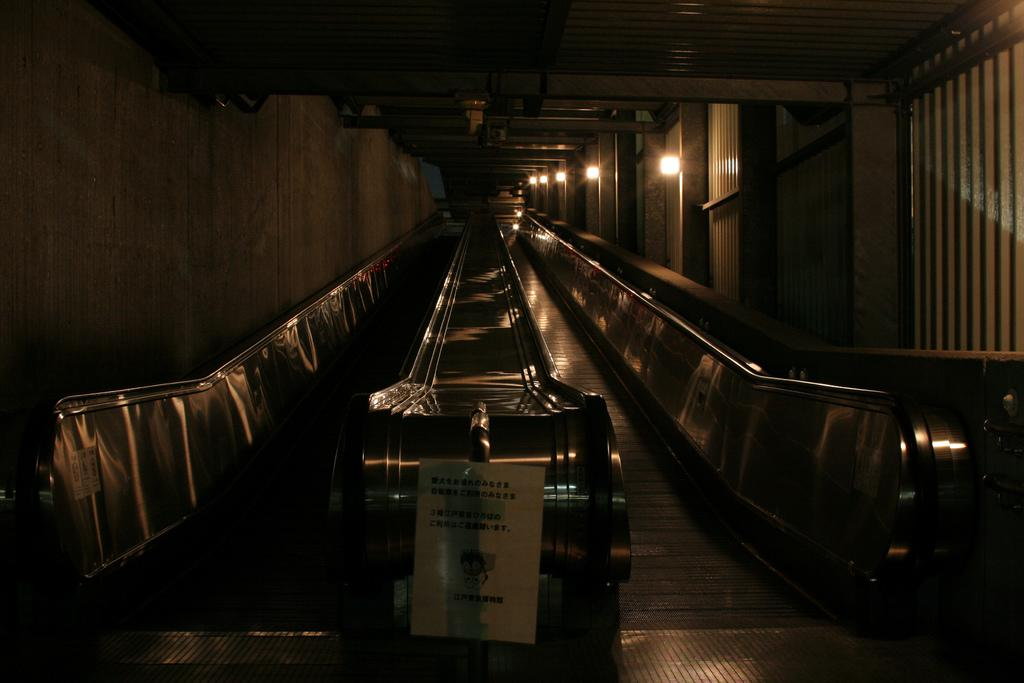What type of transportation device is present in the image? There is an escalator in the image. What is attached to the escalator? There is a poster attached to the escalator. What can be seen on the wall in the image? There are lights attached to the wall in the image. What type of tin can be seen being used by the group of people in the image? There is no tin or group of people present in the image; it only features an escalator, a poster, and lights. 